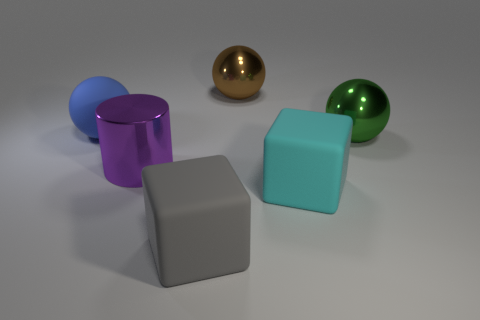Are there an equal number of gray things in front of the gray block and purple objects?
Keep it short and to the point. No. What is the shape of the large cyan rubber object?
Keep it short and to the point. Cube. There is a sphere that is in front of the big rubber sphere; is it the same size as the purple metallic thing on the right side of the blue thing?
Make the answer very short. Yes. There is a large object on the left side of the shiny object in front of the green metallic ball; what is its shape?
Your answer should be compact. Sphere. There is a brown sphere; is it the same size as the shiny ball in front of the brown metallic ball?
Offer a terse response. Yes. What number of objects are either metallic spheres that are behind the big blue ball or yellow rubber cylinders?
Keep it short and to the point. 1. There is a big cyan object that is behind the large gray matte object; how many balls are on the right side of it?
Your answer should be very brief. 1. Are there more blue balls that are left of the cyan matte block than purple metallic spheres?
Provide a short and direct response. Yes. The big object that is both behind the large green metal ball and left of the large brown metallic thing has what shape?
Offer a terse response. Sphere. There is a large shiny sphere behind the sphere that is in front of the large blue rubber object; is there a large gray block that is in front of it?
Ensure brevity in your answer.  Yes. 